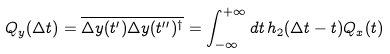Convert formula to latex. <formula><loc_0><loc_0><loc_500><loc_500>Q _ { y } ( \Delta t ) = \overline { \Delta y ( t ^ { \prime } ) \Delta y ( t ^ { \prime \prime } ) ^ { \dagger } } = \int _ { - \infty } ^ { + \infty } d t \, h _ { 2 } ( \Delta t - t ) Q _ { x } ( t )</formula> 